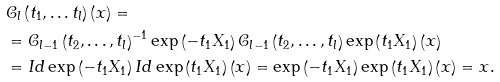<formula> <loc_0><loc_0><loc_500><loc_500>& \mathcal { C } _ { l } \left ( t _ { 1 } , \dots t _ { l } \right ) \left ( x \right ) = \\ & = \mathcal { C } _ { l - 1 } \left ( t _ { 2 } , \dots , t _ { l } \right ) ^ { - 1 } \exp \left ( - t _ { 1 } X _ { 1 } \right ) \mathcal { C } _ { l - 1 } \left ( t _ { 2 } , \dots , t _ { l } \right ) \exp \left ( t _ { 1 } X _ { 1 } \right ) \left ( x \right ) \\ & = I d \exp \left ( - t _ { 1 } X _ { 1 } \right ) I d \exp \left ( t _ { 1 } X _ { 1 } \right ) \left ( x \right ) = \exp \left ( - t _ { 1 } X _ { 1 } \right ) \exp \left ( t _ { 1 } X _ { 1 } \right ) \left ( x \right ) = x .</formula> 